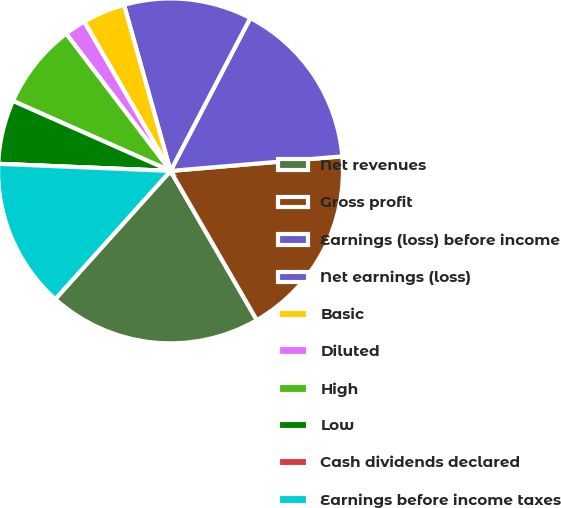<chart> <loc_0><loc_0><loc_500><loc_500><pie_chart><fcel>Net revenues<fcel>Gross profit<fcel>Earnings (loss) before income<fcel>Net earnings (loss)<fcel>Basic<fcel>Diluted<fcel>High<fcel>Low<fcel>Cash dividends declared<fcel>Earnings before income taxes<nl><fcel>20.0%<fcel>18.0%<fcel>16.0%<fcel>12.0%<fcel>4.0%<fcel>2.0%<fcel>8.0%<fcel>6.0%<fcel>0.0%<fcel>14.0%<nl></chart> 